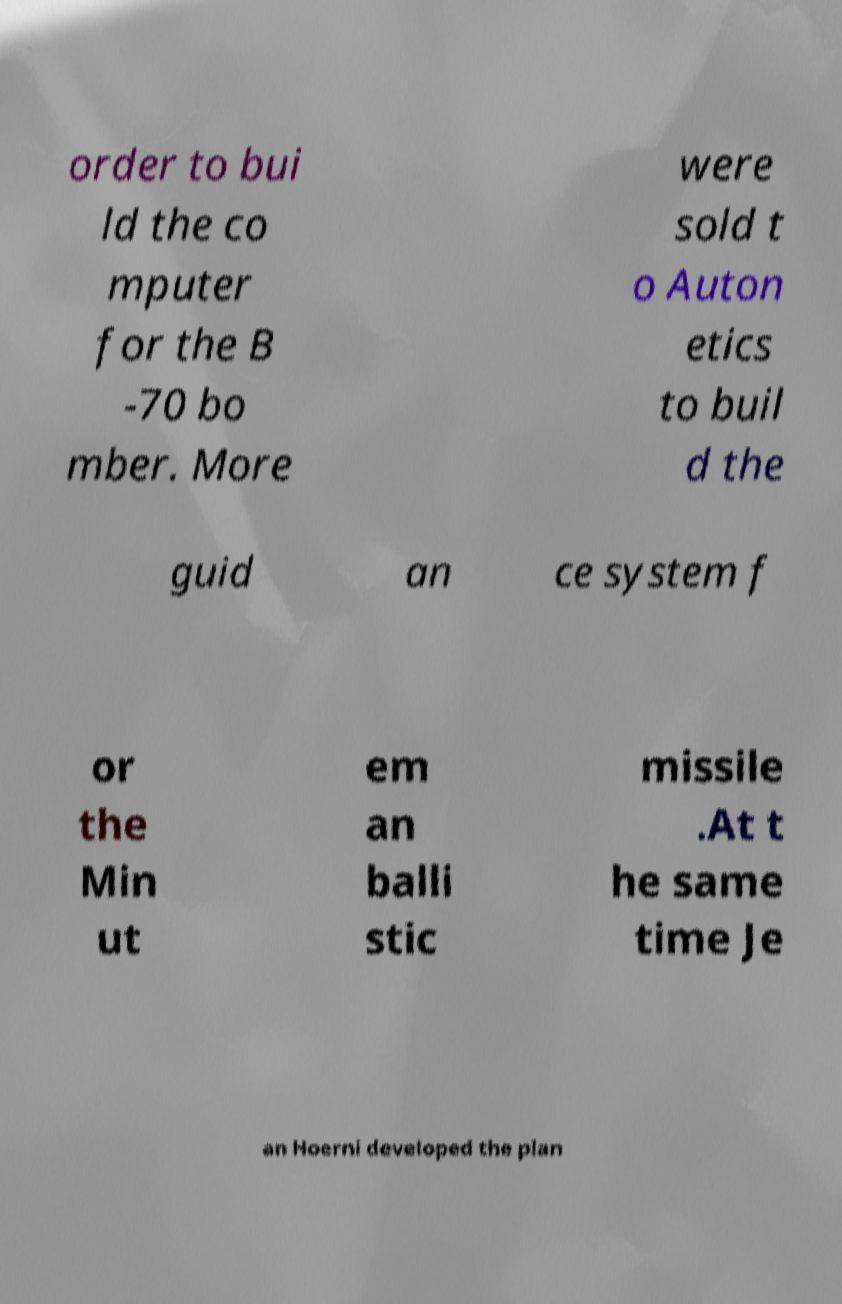Can you read and provide the text displayed in the image?This photo seems to have some interesting text. Can you extract and type it out for me? order to bui ld the co mputer for the B -70 bo mber. More were sold t o Auton etics to buil d the guid an ce system f or the Min ut em an balli stic missile .At t he same time Je an Hoerni developed the plan 